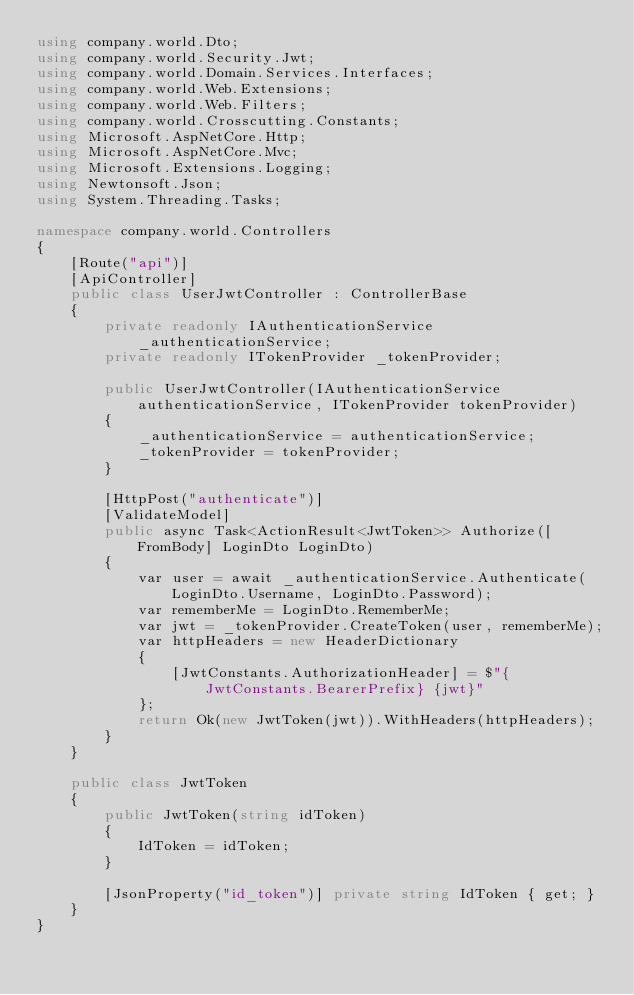Convert code to text. <code><loc_0><loc_0><loc_500><loc_500><_C#_>using company.world.Dto;
using company.world.Security.Jwt;
using company.world.Domain.Services.Interfaces;
using company.world.Web.Extensions;
using company.world.Web.Filters;
using company.world.Crosscutting.Constants;
using Microsoft.AspNetCore.Http;
using Microsoft.AspNetCore.Mvc;
using Microsoft.Extensions.Logging;
using Newtonsoft.Json;
using System.Threading.Tasks;

namespace company.world.Controllers
{
    [Route("api")]
    [ApiController]
    public class UserJwtController : ControllerBase
    {
        private readonly IAuthenticationService _authenticationService;
        private readonly ITokenProvider _tokenProvider;

        public UserJwtController(IAuthenticationService authenticationService, ITokenProvider tokenProvider)
        {
            _authenticationService = authenticationService;
            _tokenProvider = tokenProvider;
        }

        [HttpPost("authenticate")]
        [ValidateModel]
        public async Task<ActionResult<JwtToken>> Authorize([FromBody] LoginDto LoginDto)
        {
            var user = await _authenticationService.Authenticate(LoginDto.Username, LoginDto.Password);
            var rememberMe = LoginDto.RememberMe;
            var jwt = _tokenProvider.CreateToken(user, rememberMe);
            var httpHeaders = new HeaderDictionary
            {
                [JwtConstants.AuthorizationHeader] = $"{JwtConstants.BearerPrefix} {jwt}"
            };
            return Ok(new JwtToken(jwt)).WithHeaders(httpHeaders);
        }
    }

    public class JwtToken
    {
        public JwtToken(string idToken)
        {
            IdToken = idToken;
        }

        [JsonProperty("id_token")] private string IdToken { get; }
    }
}
</code> 